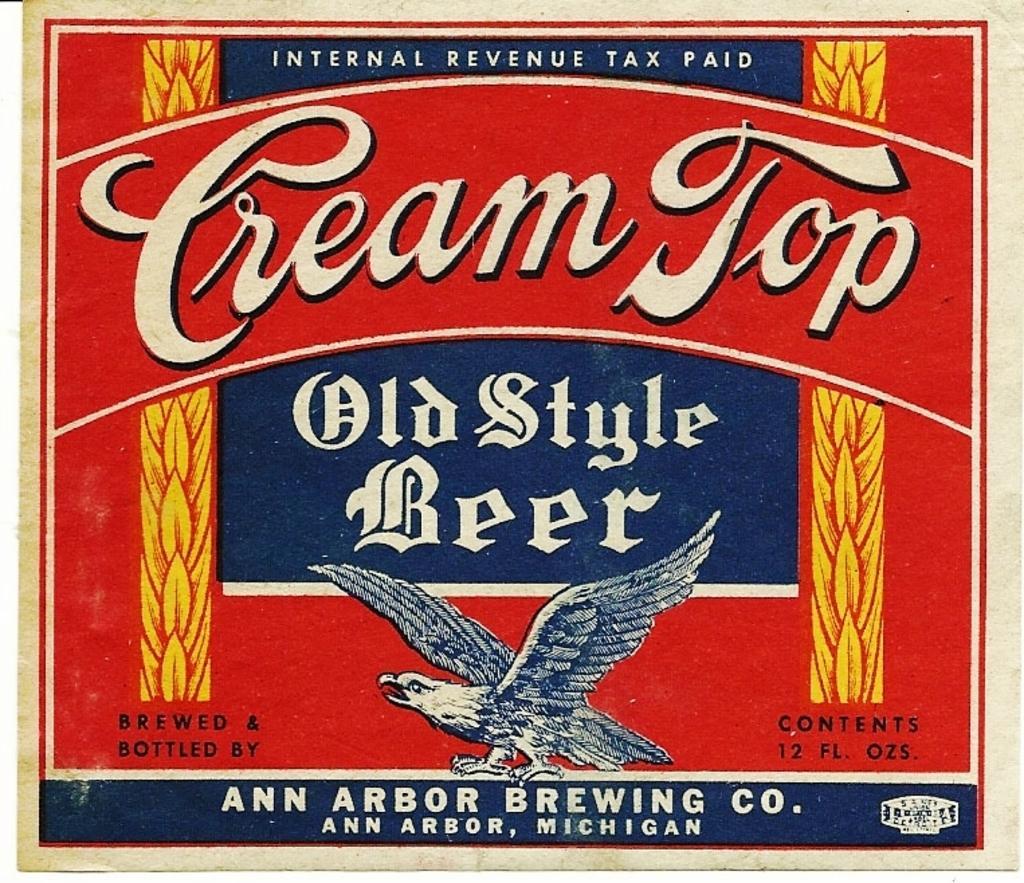Please provide a concise description of this image. There is a poster having an animated image of a bird, white color texts, yellow color designs and other colors texts. And the background of this poster is red in color. 